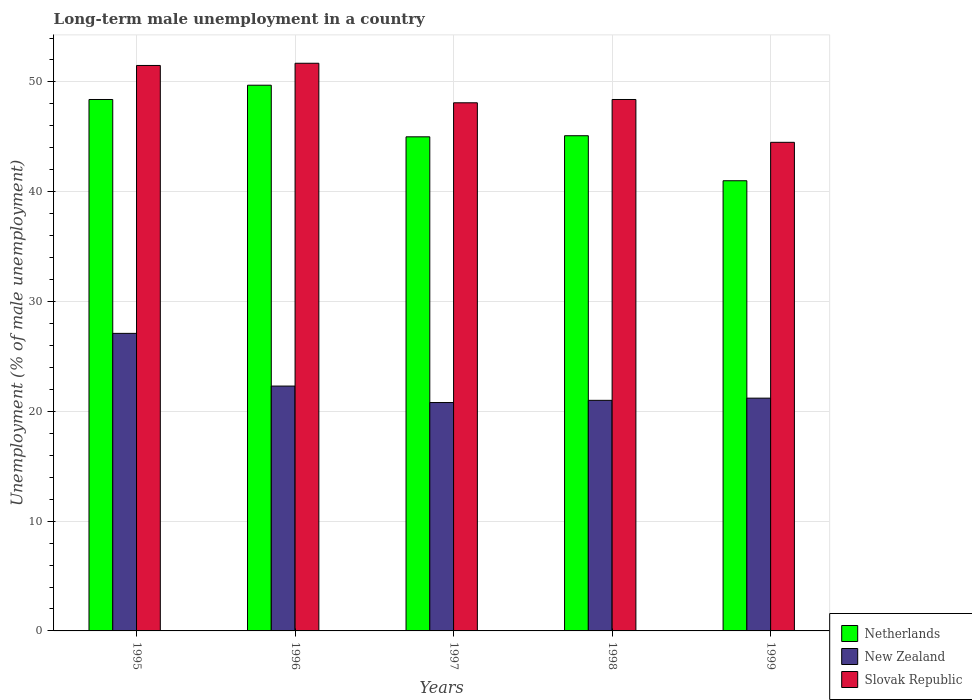How many groups of bars are there?
Give a very brief answer. 5. Are the number of bars per tick equal to the number of legend labels?
Keep it short and to the point. Yes. Are the number of bars on each tick of the X-axis equal?
Your answer should be compact. Yes. What is the label of the 3rd group of bars from the left?
Make the answer very short. 1997. What is the percentage of long-term unemployed male population in Netherlands in 1999?
Give a very brief answer. 41. Across all years, what is the maximum percentage of long-term unemployed male population in New Zealand?
Provide a succinct answer. 27.1. Across all years, what is the minimum percentage of long-term unemployed male population in Slovak Republic?
Make the answer very short. 44.5. In which year was the percentage of long-term unemployed male population in Slovak Republic maximum?
Your response must be concise. 1996. In which year was the percentage of long-term unemployed male population in Slovak Republic minimum?
Provide a short and direct response. 1999. What is the total percentage of long-term unemployed male population in Slovak Republic in the graph?
Your answer should be compact. 244.2. What is the difference between the percentage of long-term unemployed male population in Netherlands in 1996 and that in 1999?
Ensure brevity in your answer.  8.7. What is the difference between the percentage of long-term unemployed male population in New Zealand in 1997 and the percentage of long-term unemployed male population in Slovak Republic in 1996?
Ensure brevity in your answer.  -30.9. What is the average percentage of long-term unemployed male population in Slovak Republic per year?
Your answer should be compact. 48.84. In the year 1999, what is the difference between the percentage of long-term unemployed male population in Slovak Republic and percentage of long-term unemployed male population in New Zealand?
Offer a very short reply. 23.3. What is the ratio of the percentage of long-term unemployed male population in Slovak Republic in 1997 to that in 1998?
Your answer should be very brief. 0.99. Is the percentage of long-term unemployed male population in Slovak Republic in 1995 less than that in 1998?
Your answer should be compact. No. What is the difference between the highest and the second highest percentage of long-term unemployed male population in New Zealand?
Ensure brevity in your answer.  4.8. What is the difference between the highest and the lowest percentage of long-term unemployed male population in Netherlands?
Your response must be concise. 8.7. What does the 1st bar from the left in 1997 represents?
Your answer should be compact. Netherlands. What does the 1st bar from the right in 1996 represents?
Offer a very short reply. Slovak Republic. How many bars are there?
Offer a terse response. 15. Are all the bars in the graph horizontal?
Keep it short and to the point. No. What is the difference between two consecutive major ticks on the Y-axis?
Give a very brief answer. 10. Does the graph contain any zero values?
Provide a short and direct response. No. Does the graph contain grids?
Your answer should be compact. Yes. How many legend labels are there?
Ensure brevity in your answer.  3. What is the title of the graph?
Your answer should be compact. Long-term male unemployment in a country. What is the label or title of the X-axis?
Make the answer very short. Years. What is the label or title of the Y-axis?
Ensure brevity in your answer.  Unemployment (% of male unemployment). What is the Unemployment (% of male unemployment) of Netherlands in 1995?
Provide a short and direct response. 48.4. What is the Unemployment (% of male unemployment) of New Zealand in 1995?
Offer a very short reply. 27.1. What is the Unemployment (% of male unemployment) of Slovak Republic in 1995?
Give a very brief answer. 51.5. What is the Unemployment (% of male unemployment) of Netherlands in 1996?
Keep it short and to the point. 49.7. What is the Unemployment (% of male unemployment) of New Zealand in 1996?
Keep it short and to the point. 22.3. What is the Unemployment (% of male unemployment) of Slovak Republic in 1996?
Make the answer very short. 51.7. What is the Unemployment (% of male unemployment) of Netherlands in 1997?
Keep it short and to the point. 45. What is the Unemployment (% of male unemployment) of New Zealand in 1997?
Offer a terse response. 20.8. What is the Unemployment (% of male unemployment) in Slovak Republic in 1997?
Your answer should be very brief. 48.1. What is the Unemployment (% of male unemployment) of Netherlands in 1998?
Provide a succinct answer. 45.1. What is the Unemployment (% of male unemployment) in Slovak Republic in 1998?
Give a very brief answer. 48.4. What is the Unemployment (% of male unemployment) in Netherlands in 1999?
Your answer should be very brief. 41. What is the Unemployment (% of male unemployment) of New Zealand in 1999?
Offer a very short reply. 21.2. What is the Unemployment (% of male unemployment) in Slovak Republic in 1999?
Your response must be concise. 44.5. Across all years, what is the maximum Unemployment (% of male unemployment) of Netherlands?
Your answer should be very brief. 49.7. Across all years, what is the maximum Unemployment (% of male unemployment) of New Zealand?
Provide a short and direct response. 27.1. Across all years, what is the maximum Unemployment (% of male unemployment) in Slovak Republic?
Your answer should be compact. 51.7. Across all years, what is the minimum Unemployment (% of male unemployment) in Netherlands?
Make the answer very short. 41. Across all years, what is the minimum Unemployment (% of male unemployment) of New Zealand?
Provide a short and direct response. 20.8. Across all years, what is the minimum Unemployment (% of male unemployment) of Slovak Republic?
Offer a very short reply. 44.5. What is the total Unemployment (% of male unemployment) of Netherlands in the graph?
Provide a succinct answer. 229.2. What is the total Unemployment (% of male unemployment) of New Zealand in the graph?
Offer a terse response. 112.4. What is the total Unemployment (% of male unemployment) of Slovak Republic in the graph?
Offer a very short reply. 244.2. What is the difference between the Unemployment (% of male unemployment) in Netherlands in 1995 and that in 1996?
Your answer should be very brief. -1.3. What is the difference between the Unemployment (% of male unemployment) in New Zealand in 1995 and that in 1996?
Your response must be concise. 4.8. What is the difference between the Unemployment (% of male unemployment) of Slovak Republic in 1995 and that in 1996?
Your answer should be very brief. -0.2. What is the difference between the Unemployment (% of male unemployment) in Netherlands in 1995 and that in 1997?
Provide a succinct answer. 3.4. What is the difference between the Unemployment (% of male unemployment) of Netherlands in 1995 and that in 1998?
Your response must be concise. 3.3. What is the difference between the Unemployment (% of male unemployment) in Netherlands in 1995 and that in 1999?
Offer a terse response. 7.4. What is the difference between the Unemployment (% of male unemployment) in New Zealand in 1995 and that in 1999?
Keep it short and to the point. 5.9. What is the difference between the Unemployment (% of male unemployment) in Slovak Republic in 1995 and that in 1999?
Provide a short and direct response. 7. What is the difference between the Unemployment (% of male unemployment) of New Zealand in 1996 and that in 1997?
Your response must be concise. 1.5. What is the difference between the Unemployment (% of male unemployment) of Slovak Republic in 1996 and that in 1997?
Provide a short and direct response. 3.6. What is the difference between the Unemployment (% of male unemployment) of Netherlands in 1996 and that in 1998?
Offer a terse response. 4.6. What is the difference between the Unemployment (% of male unemployment) in Slovak Republic in 1996 and that in 1998?
Your response must be concise. 3.3. What is the difference between the Unemployment (% of male unemployment) in Netherlands in 1996 and that in 1999?
Make the answer very short. 8.7. What is the difference between the Unemployment (% of male unemployment) of New Zealand in 1996 and that in 1999?
Offer a very short reply. 1.1. What is the difference between the Unemployment (% of male unemployment) of Slovak Republic in 1996 and that in 1999?
Your answer should be very brief. 7.2. What is the difference between the Unemployment (% of male unemployment) in New Zealand in 1997 and that in 1998?
Offer a terse response. -0.2. What is the difference between the Unemployment (% of male unemployment) in New Zealand in 1997 and that in 1999?
Ensure brevity in your answer.  -0.4. What is the difference between the Unemployment (% of male unemployment) in Slovak Republic in 1997 and that in 1999?
Your answer should be very brief. 3.6. What is the difference between the Unemployment (% of male unemployment) in Netherlands in 1998 and that in 1999?
Offer a terse response. 4.1. What is the difference between the Unemployment (% of male unemployment) of New Zealand in 1998 and that in 1999?
Your answer should be compact. -0.2. What is the difference between the Unemployment (% of male unemployment) in Slovak Republic in 1998 and that in 1999?
Ensure brevity in your answer.  3.9. What is the difference between the Unemployment (% of male unemployment) in Netherlands in 1995 and the Unemployment (% of male unemployment) in New Zealand in 1996?
Your response must be concise. 26.1. What is the difference between the Unemployment (% of male unemployment) of New Zealand in 1995 and the Unemployment (% of male unemployment) of Slovak Republic in 1996?
Offer a terse response. -24.6. What is the difference between the Unemployment (% of male unemployment) in Netherlands in 1995 and the Unemployment (% of male unemployment) in New Zealand in 1997?
Your response must be concise. 27.6. What is the difference between the Unemployment (% of male unemployment) in Netherlands in 1995 and the Unemployment (% of male unemployment) in Slovak Republic in 1997?
Offer a very short reply. 0.3. What is the difference between the Unemployment (% of male unemployment) of New Zealand in 1995 and the Unemployment (% of male unemployment) of Slovak Republic in 1997?
Keep it short and to the point. -21. What is the difference between the Unemployment (% of male unemployment) in Netherlands in 1995 and the Unemployment (% of male unemployment) in New Zealand in 1998?
Ensure brevity in your answer.  27.4. What is the difference between the Unemployment (% of male unemployment) of New Zealand in 1995 and the Unemployment (% of male unemployment) of Slovak Republic in 1998?
Provide a succinct answer. -21.3. What is the difference between the Unemployment (% of male unemployment) in Netherlands in 1995 and the Unemployment (% of male unemployment) in New Zealand in 1999?
Provide a succinct answer. 27.2. What is the difference between the Unemployment (% of male unemployment) of Netherlands in 1995 and the Unemployment (% of male unemployment) of Slovak Republic in 1999?
Your response must be concise. 3.9. What is the difference between the Unemployment (% of male unemployment) in New Zealand in 1995 and the Unemployment (% of male unemployment) in Slovak Republic in 1999?
Give a very brief answer. -17.4. What is the difference between the Unemployment (% of male unemployment) of Netherlands in 1996 and the Unemployment (% of male unemployment) of New Zealand in 1997?
Give a very brief answer. 28.9. What is the difference between the Unemployment (% of male unemployment) of New Zealand in 1996 and the Unemployment (% of male unemployment) of Slovak Republic in 1997?
Make the answer very short. -25.8. What is the difference between the Unemployment (% of male unemployment) of Netherlands in 1996 and the Unemployment (% of male unemployment) of New Zealand in 1998?
Your response must be concise. 28.7. What is the difference between the Unemployment (% of male unemployment) in New Zealand in 1996 and the Unemployment (% of male unemployment) in Slovak Republic in 1998?
Offer a terse response. -26.1. What is the difference between the Unemployment (% of male unemployment) in Netherlands in 1996 and the Unemployment (% of male unemployment) in Slovak Republic in 1999?
Provide a succinct answer. 5.2. What is the difference between the Unemployment (% of male unemployment) in New Zealand in 1996 and the Unemployment (% of male unemployment) in Slovak Republic in 1999?
Provide a short and direct response. -22.2. What is the difference between the Unemployment (% of male unemployment) of Netherlands in 1997 and the Unemployment (% of male unemployment) of New Zealand in 1998?
Provide a short and direct response. 24. What is the difference between the Unemployment (% of male unemployment) of New Zealand in 1997 and the Unemployment (% of male unemployment) of Slovak Republic in 1998?
Keep it short and to the point. -27.6. What is the difference between the Unemployment (% of male unemployment) of Netherlands in 1997 and the Unemployment (% of male unemployment) of New Zealand in 1999?
Your answer should be very brief. 23.8. What is the difference between the Unemployment (% of male unemployment) of New Zealand in 1997 and the Unemployment (% of male unemployment) of Slovak Republic in 1999?
Your response must be concise. -23.7. What is the difference between the Unemployment (% of male unemployment) of Netherlands in 1998 and the Unemployment (% of male unemployment) of New Zealand in 1999?
Keep it short and to the point. 23.9. What is the difference between the Unemployment (% of male unemployment) in Netherlands in 1998 and the Unemployment (% of male unemployment) in Slovak Republic in 1999?
Keep it short and to the point. 0.6. What is the difference between the Unemployment (% of male unemployment) in New Zealand in 1998 and the Unemployment (% of male unemployment) in Slovak Republic in 1999?
Keep it short and to the point. -23.5. What is the average Unemployment (% of male unemployment) of Netherlands per year?
Provide a succinct answer. 45.84. What is the average Unemployment (% of male unemployment) in New Zealand per year?
Your answer should be very brief. 22.48. What is the average Unemployment (% of male unemployment) of Slovak Republic per year?
Offer a terse response. 48.84. In the year 1995, what is the difference between the Unemployment (% of male unemployment) of Netherlands and Unemployment (% of male unemployment) of New Zealand?
Offer a very short reply. 21.3. In the year 1995, what is the difference between the Unemployment (% of male unemployment) of New Zealand and Unemployment (% of male unemployment) of Slovak Republic?
Ensure brevity in your answer.  -24.4. In the year 1996, what is the difference between the Unemployment (% of male unemployment) of Netherlands and Unemployment (% of male unemployment) of New Zealand?
Give a very brief answer. 27.4. In the year 1996, what is the difference between the Unemployment (% of male unemployment) of New Zealand and Unemployment (% of male unemployment) of Slovak Republic?
Give a very brief answer. -29.4. In the year 1997, what is the difference between the Unemployment (% of male unemployment) of Netherlands and Unemployment (% of male unemployment) of New Zealand?
Keep it short and to the point. 24.2. In the year 1997, what is the difference between the Unemployment (% of male unemployment) in Netherlands and Unemployment (% of male unemployment) in Slovak Republic?
Your response must be concise. -3.1. In the year 1997, what is the difference between the Unemployment (% of male unemployment) of New Zealand and Unemployment (% of male unemployment) of Slovak Republic?
Keep it short and to the point. -27.3. In the year 1998, what is the difference between the Unemployment (% of male unemployment) of Netherlands and Unemployment (% of male unemployment) of New Zealand?
Keep it short and to the point. 24.1. In the year 1998, what is the difference between the Unemployment (% of male unemployment) in New Zealand and Unemployment (% of male unemployment) in Slovak Republic?
Make the answer very short. -27.4. In the year 1999, what is the difference between the Unemployment (% of male unemployment) of Netherlands and Unemployment (% of male unemployment) of New Zealand?
Give a very brief answer. 19.8. In the year 1999, what is the difference between the Unemployment (% of male unemployment) of Netherlands and Unemployment (% of male unemployment) of Slovak Republic?
Make the answer very short. -3.5. In the year 1999, what is the difference between the Unemployment (% of male unemployment) in New Zealand and Unemployment (% of male unemployment) in Slovak Republic?
Provide a succinct answer. -23.3. What is the ratio of the Unemployment (% of male unemployment) of Netherlands in 1995 to that in 1996?
Give a very brief answer. 0.97. What is the ratio of the Unemployment (% of male unemployment) in New Zealand in 1995 to that in 1996?
Provide a succinct answer. 1.22. What is the ratio of the Unemployment (% of male unemployment) of Slovak Republic in 1995 to that in 1996?
Provide a succinct answer. 1. What is the ratio of the Unemployment (% of male unemployment) of Netherlands in 1995 to that in 1997?
Your answer should be compact. 1.08. What is the ratio of the Unemployment (% of male unemployment) of New Zealand in 1995 to that in 1997?
Your answer should be compact. 1.3. What is the ratio of the Unemployment (% of male unemployment) of Slovak Republic in 1995 to that in 1997?
Your answer should be very brief. 1.07. What is the ratio of the Unemployment (% of male unemployment) of Netherlands in 1995 to that in 1998?
Make the answer very short. 1.07. What is the ratio of the Unemployment (% of male unemployment) of New Zealand in 1995 to that in 1998?
Your response must be concise. 1.29. What is the ratio of the Unemployment (% of male unemployment) in Slovak Republic in 1995 to that in 1998?
Provide a succinct answer. 1.06. What is the ratio of the Unemployment (% of male unemployment) in Netherlands in 1995 to that in 1999?
Offer a terse response. 1.18. What is the ratio of the Unemployment (% of male unemployment) of New Zealand in 1995 to that in 1999?
Your answer should be compact. 1.28. What is the ratio of the Unemployment (% of male unemployment) of Slovak Republic in 1995 to that in 1999?
Offer a very short reply. 1.16. What is the ratio of the Unemployment (% of male unemployment) of Netherlands in 1996 to that in 1997?
Give a very brief answer. 1.1. What is the ratio of the Unemployment (% of male unemployment) of New Zealand in 1996 to that in 1997?
Your response must be concise. 1.07. What is the ratio of the Unemployment (% of male unemployment) in Slovak Republic in 1996 to that in 1997?
Your response must be concise. 1.07. What is the ratio of the Unemployment (% of male unemployment) of Netherlands in 1996 to that in 1998?
Make the answer very short. 1.1. What is the ratio of the Unemployment (% of male unemployment) in New Zealand in 1996 to that in 1998?
Keep it short and to the point. 1.06. What is the ratio of the Unemployment (% of male unemployment) in Slovak Republic in 1996 to that in 1998?
Offer a very short reply. 1.07. What is the ratio of the Unemployment (% of male unemployment) in Netherlands in 1996 to that in 1999?
Ensure brevity in your answer.  1.21. What is the ratio of the Unemployment (% of male unemployment) of New Zealand in 1996 to that in 1999?
Your answer should be very brief. 1.05. What is the ratio of the Unemployment (% of male unemployment) of Slovak Republic in 1996 to that in 1999?
Give a very brief answer. 1.16. What is the ratio of the Unemployment (% of male unemployment) of Slovak Republic in 1997 to that in 1998?
Ensure brevity in your answer.  0.99. What is the ratio of the Unemployment (% of male unemployment) of Netherlands in 1997 to that in 1999?
Offer a terse response. 1.1. What is the ratio of the Unemployment (% of male unemployment) in New Zealand in 1997 to that in 1999?
Ensure brevity in your answer.  0.98. What is the ratio of the Unemployment (% of male unemployment) in Slovak Republic in 1997 to that in 1999?
Give a very brief answer. 1.08. What is the ratio of the Unemployment (% of male unemployment) of New Zealand in 1998 to that in 1999?
Give a very brief answer. 0.99. What is the ratio of the Unemployment (% of male unemployment) of Slovak Republic in 1998 to that in 1999?
Make the answer very short. 1.09. What is the difference between the highest and the second highest Unemployment (% of male unemployment) in Netherlands?
Keep it short and to the point. 1.3. What is the difference between the highest and the lowest Unemployment (% of male unemployment) in Netherlands?
Give a very brief answer. 8.7. What is the difference between the highest and the lowest Unemployment (% of male unemployment) of New Zealand?
Your answer should be very brief. 6.3. 